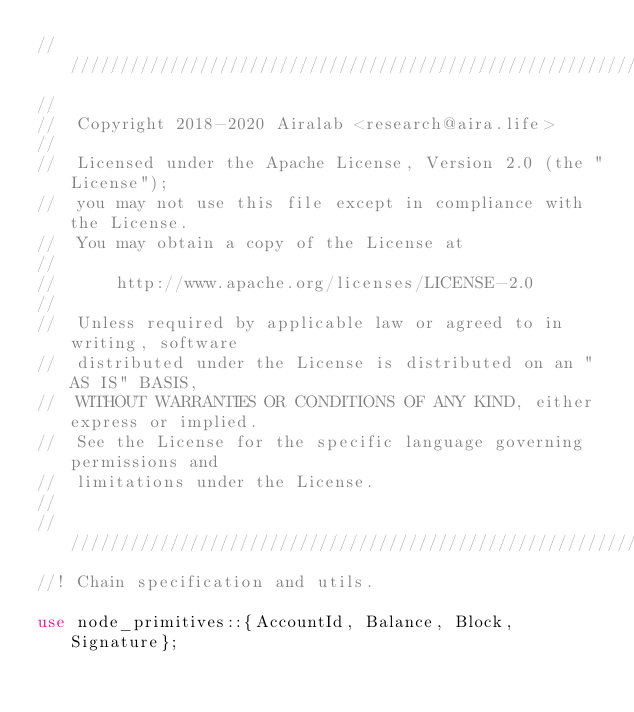<code> <loc_0><loc_0><loc_500><loc_500><_Rust_>///////////////////////////////////////////////////////////////////////////////
//
//  Copyright 2018-2020 Airalab <research@aira.life>
//
//  Licensed under the Apache License, Version 2.0 (the "License");
//  you may not use this file except in compliance with the License.
//  You may obtain a copy of the License at
//
//      http://www.apache.org/licenses/LICENSE-2.0
//
//  Unless required by applicable law or agreed to in writing, software
//  distributed under the License is distributed on an "AS IS" BASIS,
//  WITHOUT WARRANTIES OR CONDITIONS OF ANY KIND, either express or implied.
//  See the License for the specific language governing permissions and
//  limitations under the License.
//
///////////////////////////////////////////////////////////////////////////////
//! Chain specification and utils.

use node_primitives::{AccountId, Balance, Block, Signature};</code> 